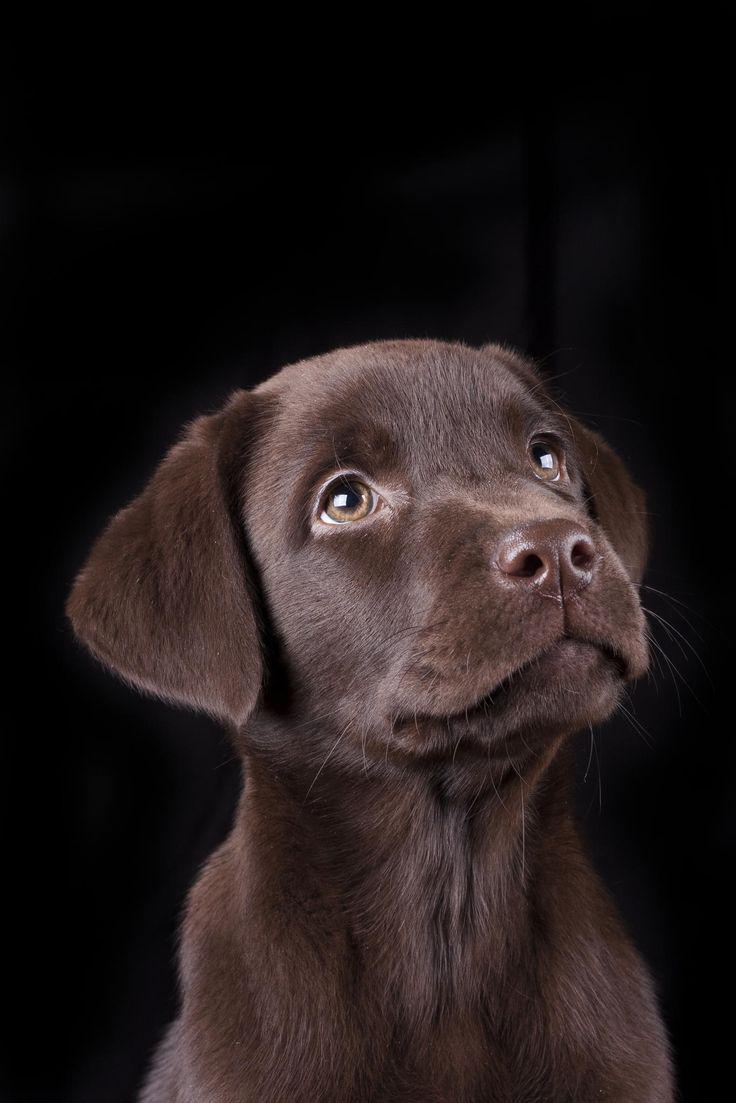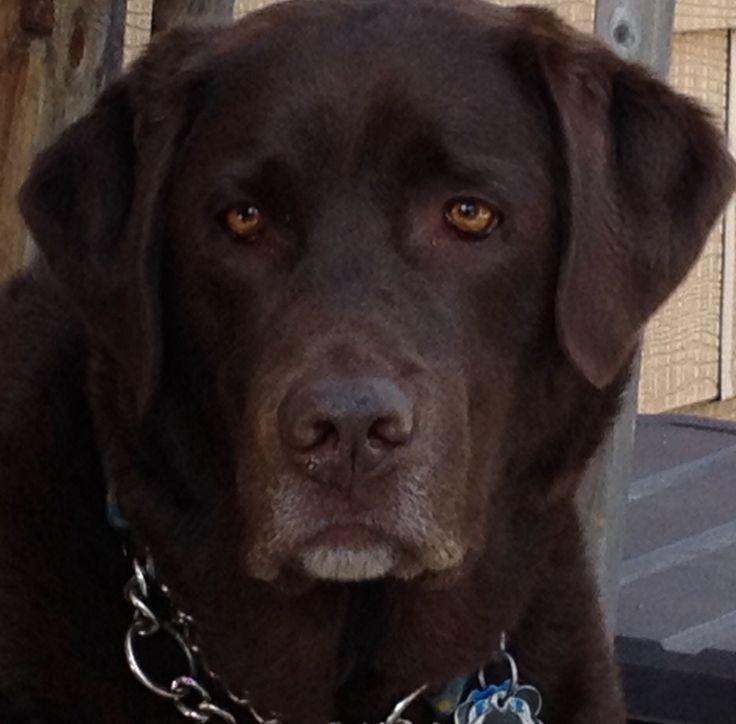The first image is the image on the left, the second image is the image on the right. Given the left and right images, does the statement "An image shows one young dog looking upward and to one side." hold true? Answer yes or no. Yes. The first image is the image on the left, the second image is the image on the right. Considering the images on both sides, is "The dog in the image on the left is not looking at the camera." valid? Answer yes or no. Yes. 